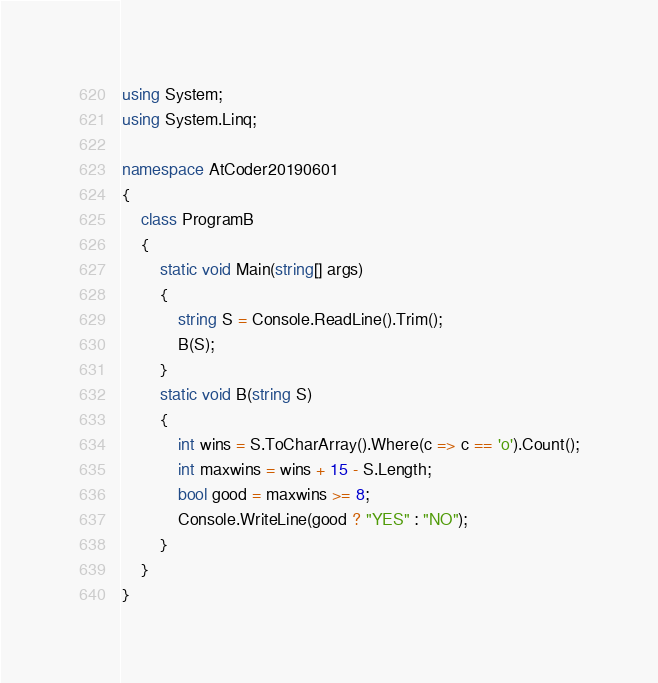<code> <loc_0><loc_0><loc_500><loc_500><_C#_>using System;
using System.Linq;

namespace AtCoder20190601
{
	class ProgramB
	{
		static void Main(string[] args)
		{
			string S = Console.ReadLine().Trim();
			B(S);
		}
		static void B(string S)
		{
			int wins = S.ToCharArray().Where(c => c == 'o').Count();
			int maxwins = wins + 15 - S.Length;
			bool good = maxwins >= 8;
			Console.WriteLine(good ? "YES" : "NO");
		}
	}
}</code> 